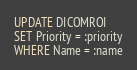<code> <loc_0><loc_0><loc_500><loc_500><_SQL_>UPDATE DICOMROI
SET Priority = :priority
WHERE Name = :name</code> 